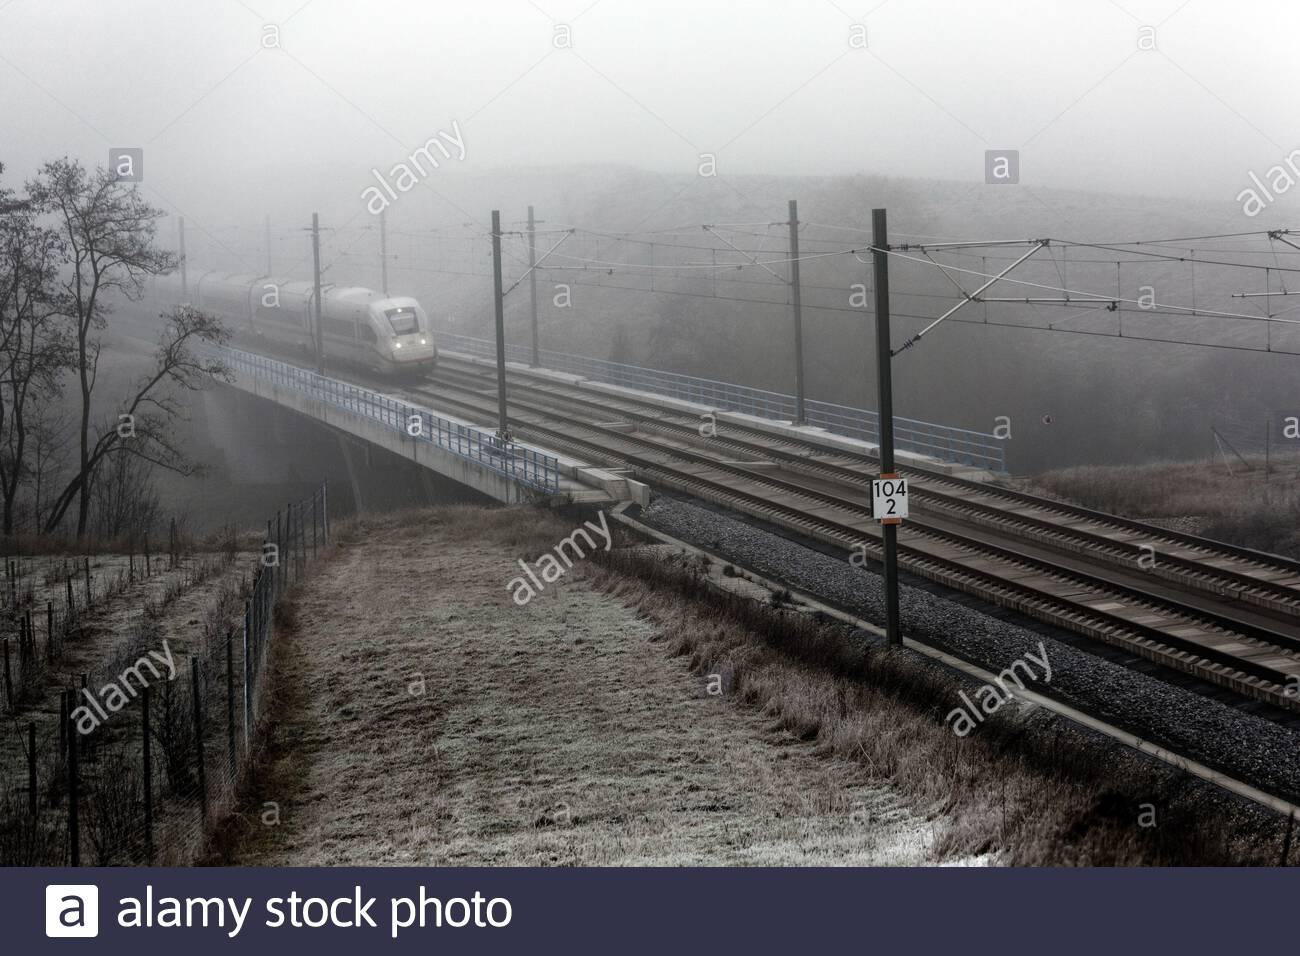Describe the setting of the image. The photo captures a train crossing a bridge in a rural area, surrounded by sparse vegetation and a frost-covered landscape, suggesting it might be early winter or late fall. Is there any special engineering visible in the image? Yes, the image shows an advanced rail system with overhead electrical lines, which are typical for modern and efficient high-speed rail networks. 